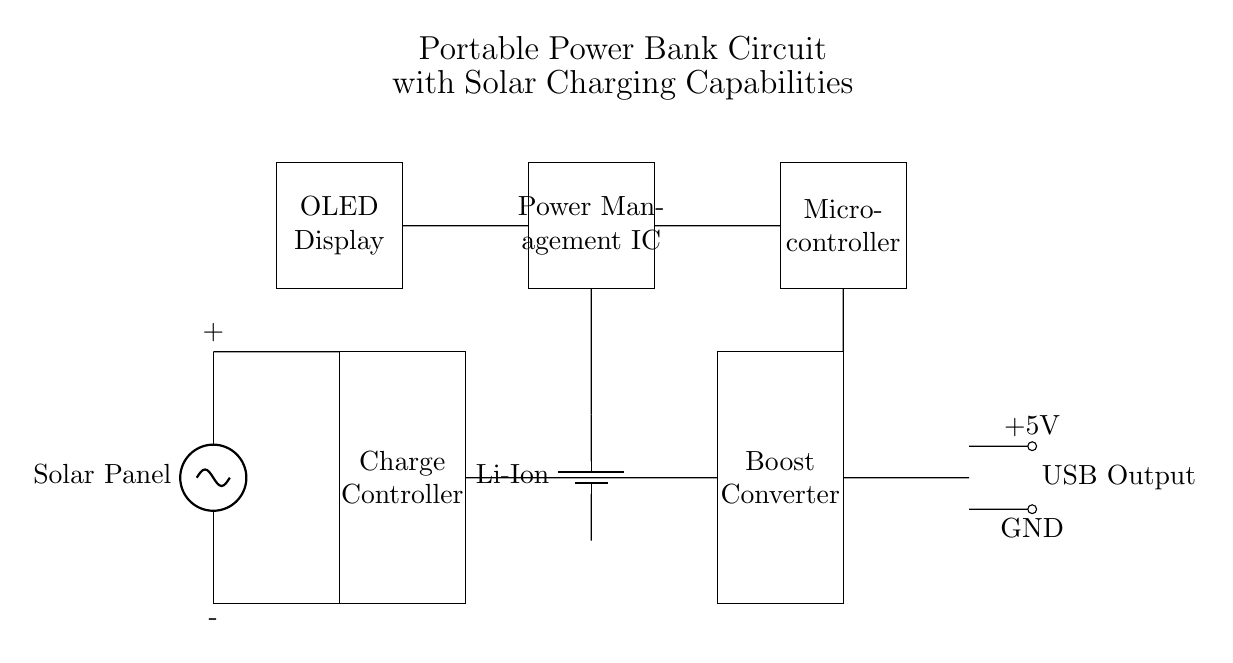What type of battery is used in this circuit? The circuit shows a component labeled as "Li-Ion," indicating that a Lithium-Ion battery is used for energy storage.
Answer: Lithium-Ion What is the function of the boost converter? The boost converter's role is to increase the voltage level provided by the battery to a higher level suitable for USB output, maintaining the necessary voltage for connected devices.
Answer: Increase voltage How many USB output ports are there in the circuit? The diagram depicts two short output connections labeled as "USB Output," indicating that there are two output ports available for charging devices.
Answer: Two What is the purpose of the power management IC? The power management integrated circuit (IC) regulates the distribution of power from the battery and the solar panel, ensuring that the system operates efficiently and protecting against overcharging.
Answer: Regulation and protection What is the voltage output specification illustrated in the circuit? The circuit shows "+5V" indicated at the USB output area, specifying the nominal output voltage that the device provides for charging.
Answer: 5 volts What component is responsible for collecting solar energy? The circuit includes a component labeled "Solar Panel," which is responsible for harnessing solar energy and converting it into electrical energy for charging the battery.
Answer: Solar Panel What displays the system's charging status? An "OLED Display" is present in the circuit, where various operational information, including charging status, can be shown for user interaction.
Answer: OLED Display 